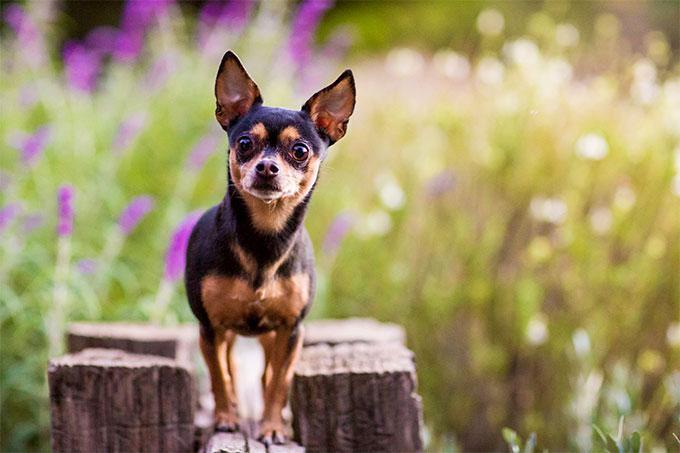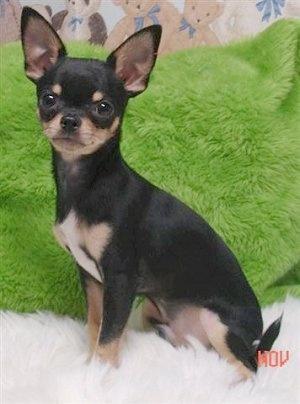The first image is the image on the left, the second image is the image on the right. Given the left and right images, does the statement "At least one dog is sitting." hold true? Answer yes or no. Yes. 